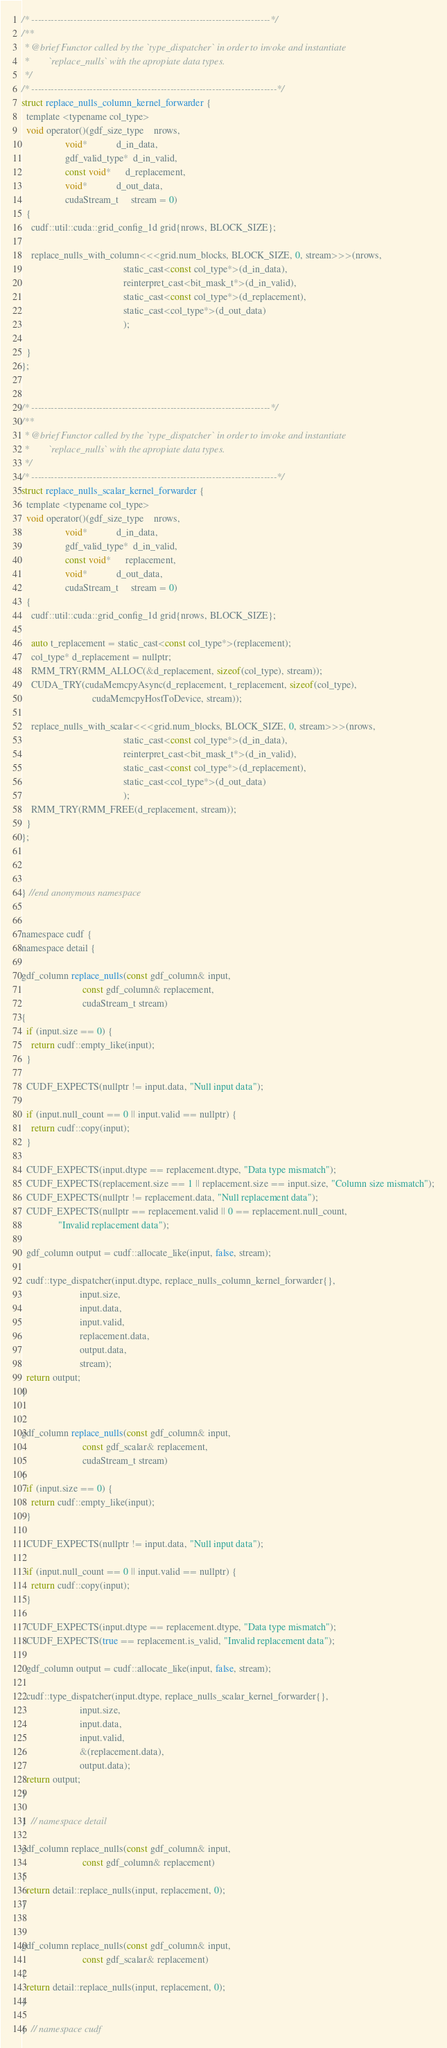Convert code to text. <code><loc_0><loc_0><loc_500><loc_500><_Cuda_>/* --------------------------------------------------------------------------*/
/**
 * @brief Functor called by the `type_dispatcher` in order to invoke and instantiate
 *        `replace_nulls` with the apropiate data types.
 */
/* ----------------------------------------------------------------------------*/
struct replace_nulls_column_kernel_forwarder {
  template <typename col_type>
  void operator()(gdf_size_type    nrows,
                  void*            d_in_data,
                  gdf_valid_type*  d_in_valid,
                  const void*      d_replacement,
                  void*            d_out_data,
                  cudaStream_t     stream = 0)
  {
    cudf::util::cuda::grid_config_1d grid{nrows, BLOCK_SIZE};

    replace_nulls_with_column<<<grid.num_blocks, BLOCK_SIZE, 0, stream>>>(nrows,
                                          static_cast<const col_type*>(d_in_data),
                                          reinterpret_cast<bit_mask_t*>(d_in_valid),
                                          static_cast<const col_type*>(d_replacement),
                                          static_cast<col_type*>(d_out_data)
                                          );

  }
};


/* --------------------------------------------------------------------------*/
/**
 * @brief Functor called by the `type_dispatcher` in order to invoke and instantiate
 *        `replace_nulls` with the apropiate data types.
 */
/* ----------------------------------------------------------------------------*/
struct replace_nulls_scalar_kernel_forwarder {
  template <typename col_type>
  void operator()(gdf_size_type    nrows,
                  void*            d_in_data,
                  gdf_valid_type*  d_in_valid,
                  const void*      replacement,
                  void*            d_out_data,
                  cudaStream_t     stream = 0)
  {
    cudf::util::cuda::grid_config_1d grid{nrows, BLOCK_SIZE};

    auto t_replacement = static_cast<const col_type*>(replacement);
    col_type* d_replacement = nullptr;
    RMM_TRY(RMM_ALLOC(&d_replacement, sizeof(col_type), stream));
    CUDA_TRY(cudaMemcpyAsync(d_replacement, t_replacement, sizeof(col_type),
                             cudaMemcpyHostToDevice, stream));

    replace_nulls_with_scalar<<<grid.num_blocks, BLOCK_SIZE, 0, stream>>>(nrows,
                                          static_cast<const col_type*>(d_in_data),
                                          reinterpret_cast<bit_mask_t*>(d_in_valid),
                                          static_cast<const col_type*>(d_replacement),
                                          static_cast<col_type*>(d_out_data)
                                          );
    RMM_TRY(RMM_FREE(d_replacement, stream));
  }
};



} //end anonymous namespace


namespace cudf {
namespace detail {

gdf_column replace_nulls(const gdf_column& input,
                         const gdf_column& replacement,
                         cudaStream_t stream)
{
  if (input.size == 0) {
    return cudf::empty_like(input);
  }

  CUDF_EXPECTS(nullptr != input.data, "Null input data");

  if (input.null_count == 0 || input.valid == nullptr) {
    return cudf::copy(input);
  }

  CUDF_EXPECTS(input.dtype == replacement.dtype, "Data type mismatch");
  CUDF_EXPECTS(replacement.size == 1 || replacement.size == input.size, "Column size mismatch");
  CUDF_EXPECTS(nullptr != replacement.data, "Null replacement data");
  CUDF_EXPECTS(nullptr == replacement.valid || 0 == replacement.null_count,
               "Invalid replacement data");

  gdf_column output = cudf::allocate_like(input, false, stream);

  cudf::type_dispatcher(input.dtype, replace_nulls_column_kernel_forwarder{},
                        input.size,
                        input.data,
                        input.valid,
                        replacement.data,
                        output.data,
                        stream);
  return output;
}


gdf_column replace_nulls(const gdf_column& input,
                         const gdf_scalar& replacement,
                         cudaStream_t stream)
{
  if (input.size == 0) {
    return cudf::empty_like(input);
  }

  CUDF_EXPECTS(nullptr != input.data, "Null input data");

  if (input.null_count == 0 || input.valid == nullptr) {
    return cudf::copy(input);
  }

  CUDF_EXPECTS(input.dtype == replacement.dtype, "Data type mismatch");
  CUDF_EXPECTS(true == replacement.is_valid, "Invalid replacement data");

  gdf_column output = cudf::allocate_like(input, false, stream);

  cudf::type_dispatcher(input.dtype, replace_nulls_scalar_kernel_forwarder{},
                        input.size,
                        input.data,
                        input.valid,
                        &(replacement.data),
                        output.data);
  return output;
}

}  // namespace detail

gdf_column replace_nulls(const gdf_column& input,
                         const gdf_column& replacement)
{
  return detail::replace_nulls(input, replacement, 0);
}


gdf_column replace_nulls(const gdf_column& input,
                         const gdf_scalar& replacement)
{
  return detail::replace_nulls(input, replacement, 0);
}

}  // namespace cudf

</code> 